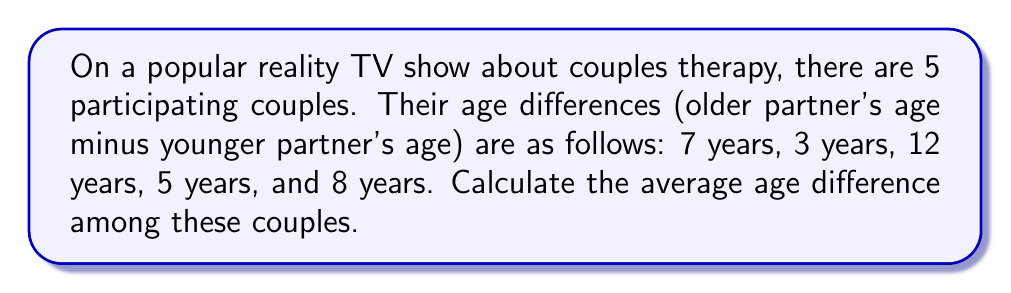Could you help me with this problem? To find the average age difference, we need to:

1. Sum up all the age differences
2. Divide the sum by the number of couples

Let's follow these steps:

1. Sum of age differences:
   $7 + 3 + 12 + 5 + 8 = 35$ years

2. Number of couples: 5

3. Calculate the average:
   $\text{Average} = \frac{\text{Sum of age differences}}{\text{Number of couples}}$

   $\text{Average} = \frac{35}{5} = 7$ years

Therefore, the average age difference between couples on this reality TV show is 7 years.
Answer: $7$ years 